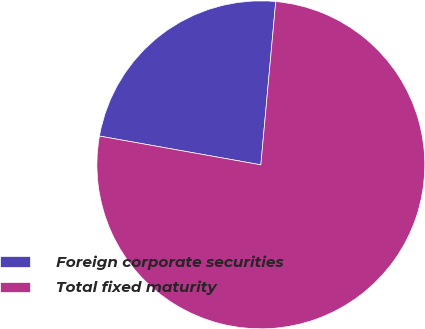Convert chart to OTSL. <chart><loc_0><loc_0><loc_500><loc_500><pie_chart><fcel>Foreign corporate securities<fcel>Total fixed maturity<nl><fcel>23.64%<fcel>76.36%<nl></chart> 